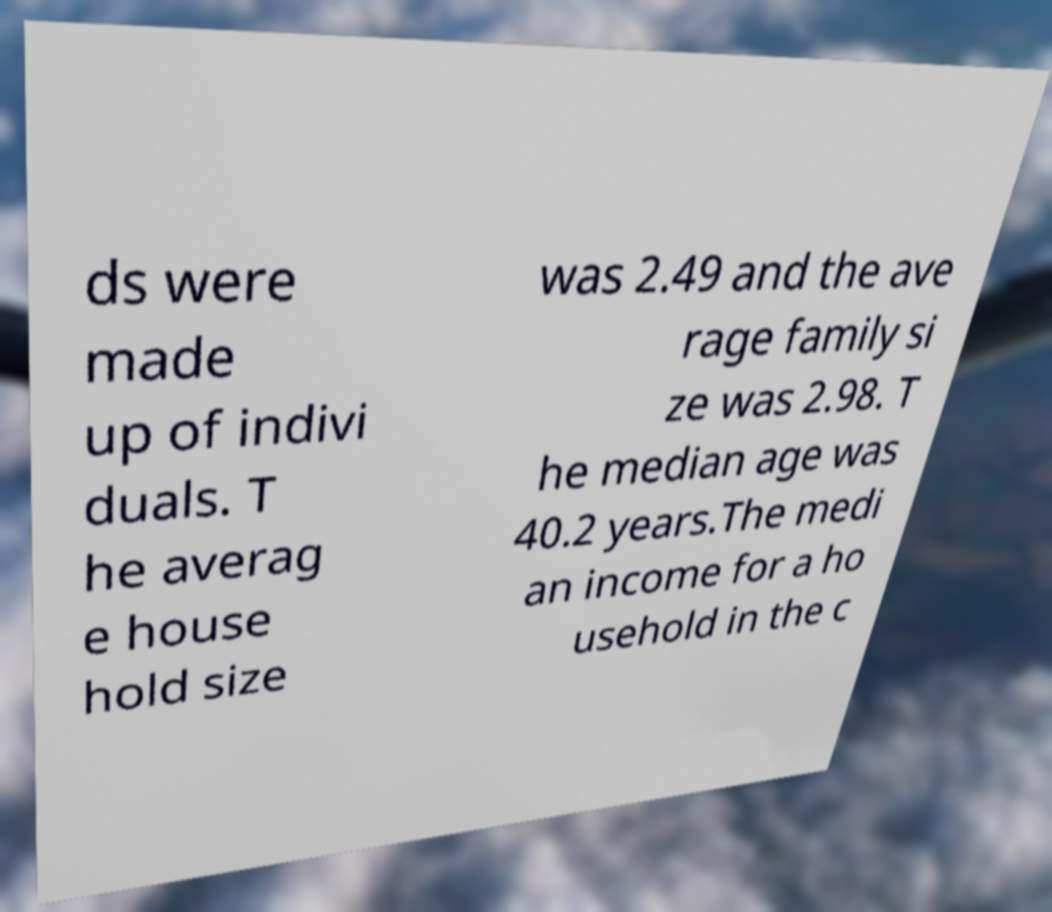For documentation purposes, I need the text within this image transcribed. Could you provide that? ds were made up of indivi duals. T he averag e house hold size was 2.49 and the ave rage family si ze was 2.98. T he median age was 40.2 years.The medi an income for a ho usehold in the c 